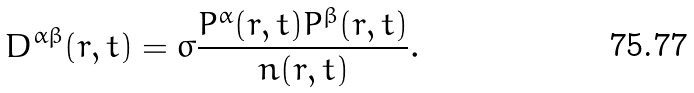Convert formula to latex. <formula><loc_0><loc_0><loc_500><loc_500>D ^ { \alpha \beta } ( r , t ) = \sigma \frac { P ^ { \alpha } ( r , t ) P ^ { \beta } ( r , t ) } { n ( r , t ) } .</formula> 